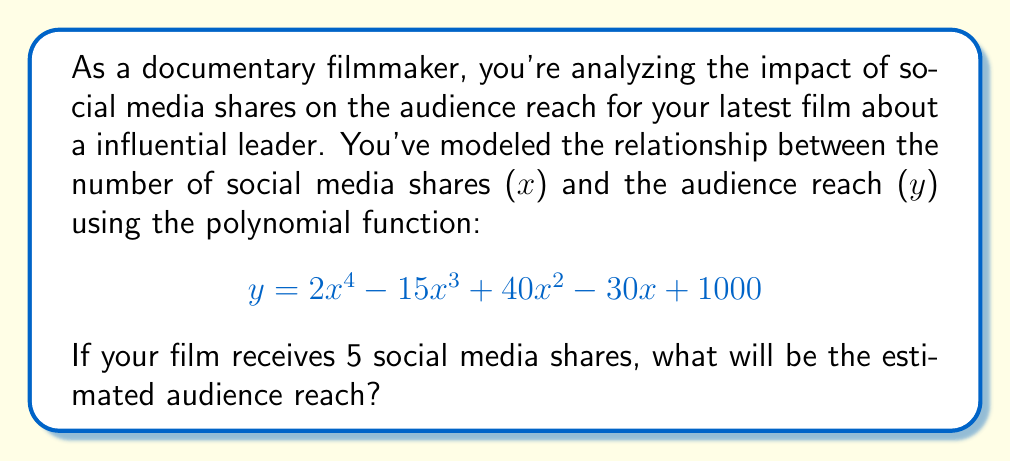Can you solve this math problem? To solve this problem, we need to substitute x = 5 into the given polynomial function and calculate the result. Let's break it down step by step:

1) The function is: $$y = 2x^4 - 15x^3 + 40x^2 - 30x + 1000$$

2) Substitute x = 5:
   $$y = 2(5^4) - 15(5^3) + 40(5^2) - 30(5) + 1000$$

3) Calculate each term:
   - $2(5^4) = 2(625) = 1250$
   - $15(5^3) = 15(125) = 1875$
   - $40(5^2) = 40(25) = 1000$
   - $30(5) = 150$
   - The constant term is 1000

4) Now our equation looks like:
   $$y = 1250 - 1875 + 1000 - 150 + 1000$$

5) Simplify:
   $$y = 1225$$

Therefore, with 5 social media shares, the estimated audience reach for your documentary will be 1225.
Answer: 1225 